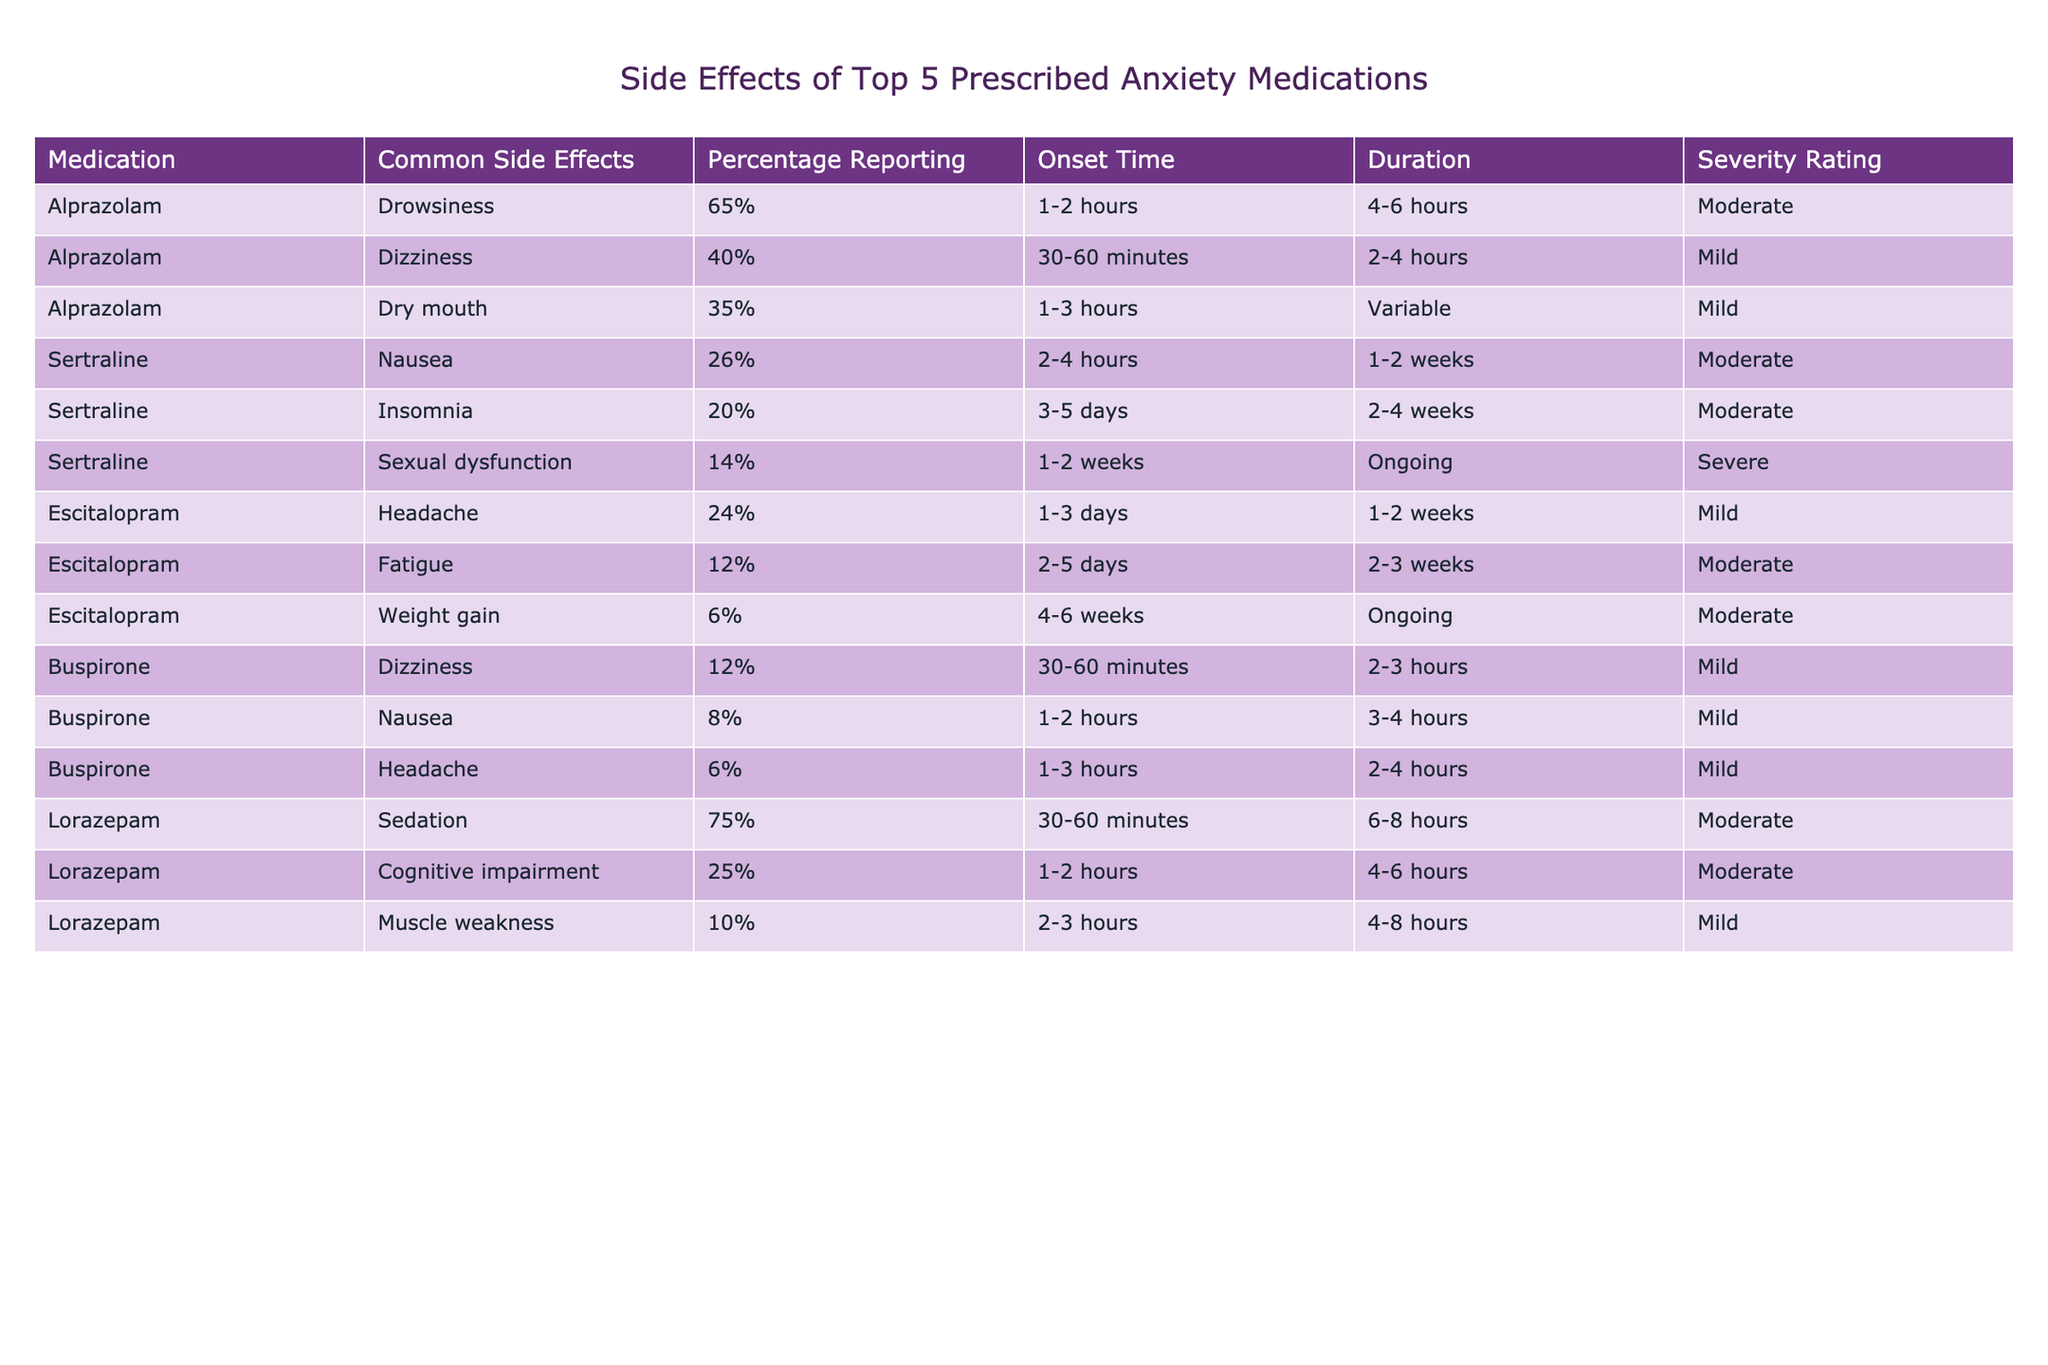What is the most common side effect reported for Alprazolam? The table indicates that the common side effect for Alprazolam is drowsiness, with 65% of users reporting it.
Answer: Drowsiness Which anxiety medication has the highest percentage of reported sedation? According to the table, Lorazepam has the highest percentage of reported sedation at 75%.
Answer: Lorazepam How many medications have a common side effect of dizziness? Looking at the table, both Alprazolam and Buspirone list dizziness as a common side effect. Therefore, there are two medications with this side effect.
Answer: 2 What is the severity rating for sexual dysfunction as a side effect for Sertraline? The table states that sexual dysfunction for Sertraline has a severity rating of severe.
Answer: Severe Which side effect has the longest average onset time for medications listed? Analyzing the onset times, the side effect "Sexual dysfunction" for Sertraline has the longest average onset time of 1-2 weeks compared to others.
Answer: Sexual dysfunction What is the difference in percentage reporting between drowsiness and dizziness for Alprazolam? Drowsiness is reported by 65% of users, and dizziness is reported by 40%. The difference is 65% - 40% = 25%.
Answer: 25% Which medication has the least reported side effect of weight gain, and what is the percentage? Escitalopram has the least reported side effect of weight gain at 6%.
Answer: Escitalopram, 6% True or False: All medications listed have at least one common side effect rated as moderate. Referring to the table, both Escitalopram and Buspirone have common side effects rated as mild, making the statement false.
Answer: False What is the total number of reports for common side effects (adding all percentages) listed for Lorazepam? The common side effects reported for Lorazepam are 75% (sedation), 25% (cognitive impairment), and 10% (muscle weakness). Summing these gives 75 + 25 + 10 = 110%.
Answer: 110% Which medication has a common side effect that is both moderate in severity and occurs with a 75% reporting rate? The table shows that Lorazepam has a common side effect of sedation with a reporting rate of 75% and a severity rating of moderate.
Answer: Lorazepam 